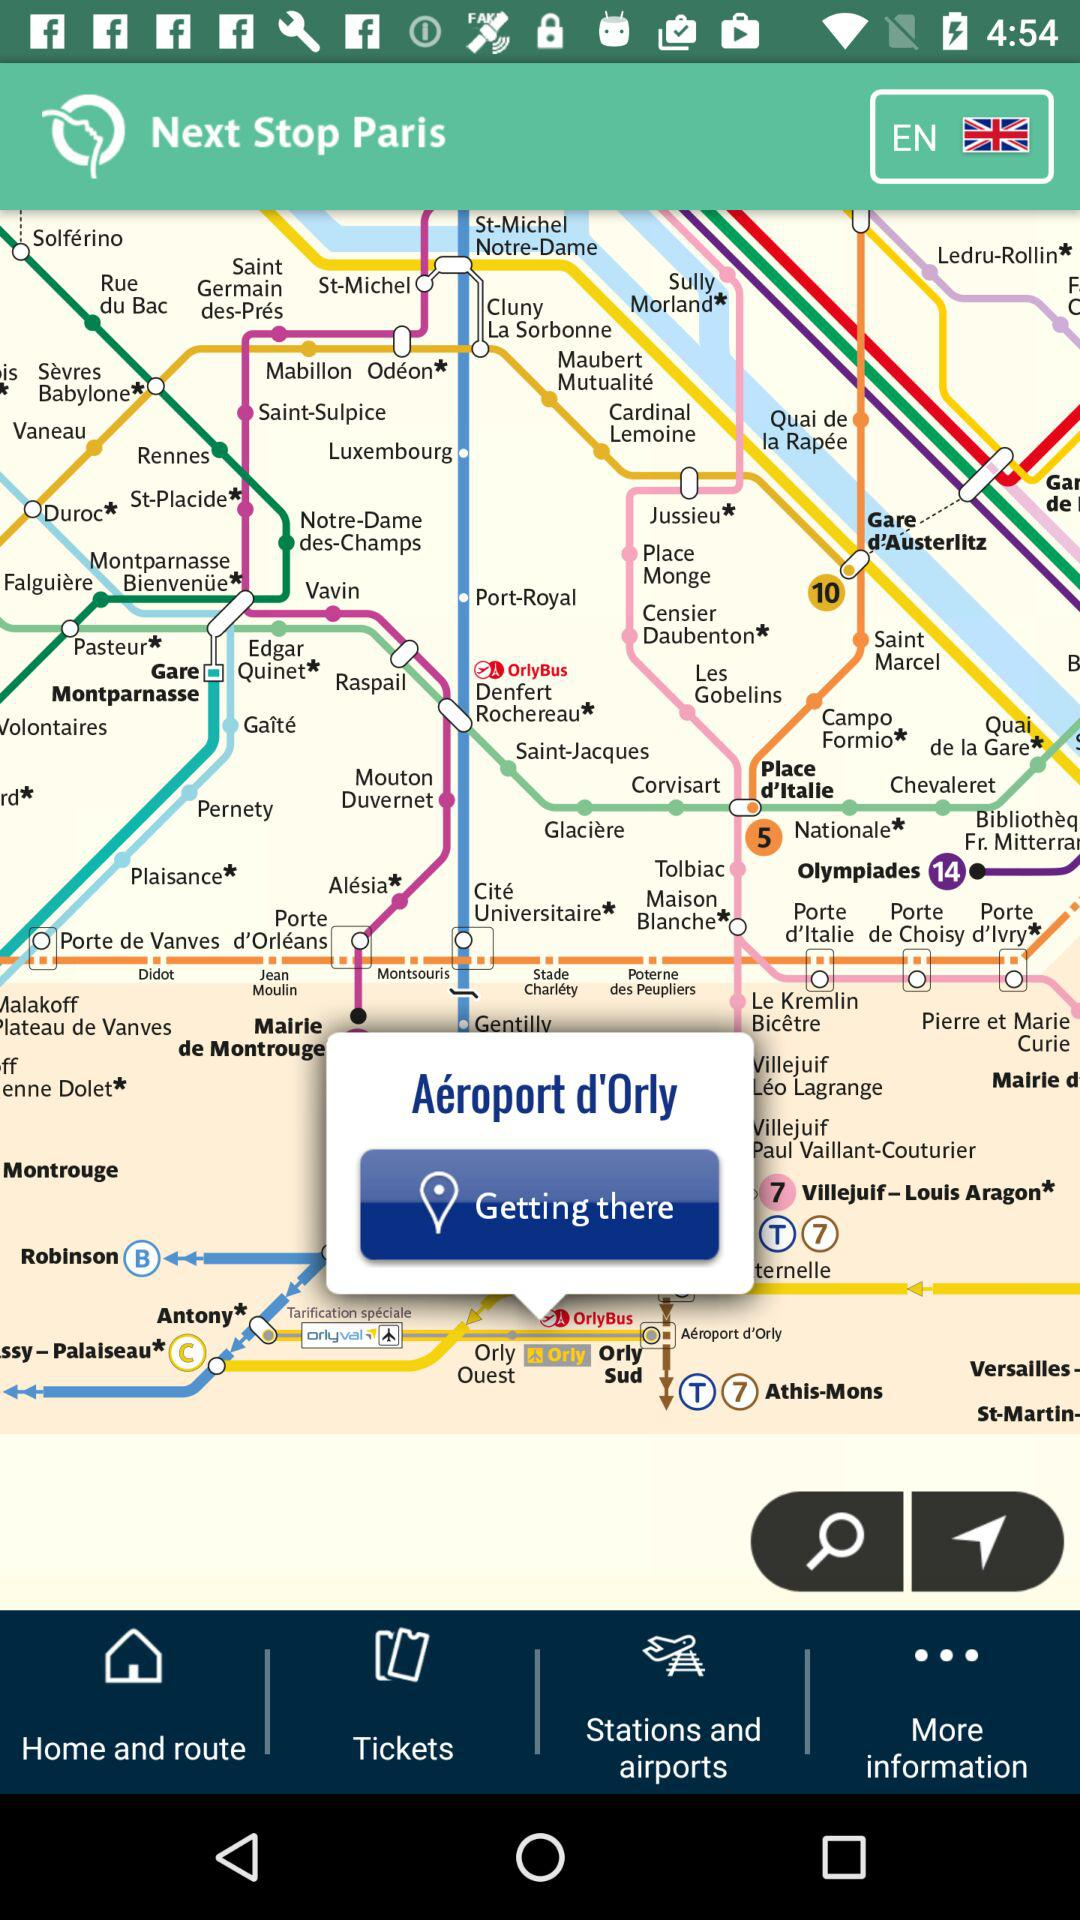What is the next stop?
When the provided information is insufficient, respond with <no answer>. <no answer> 